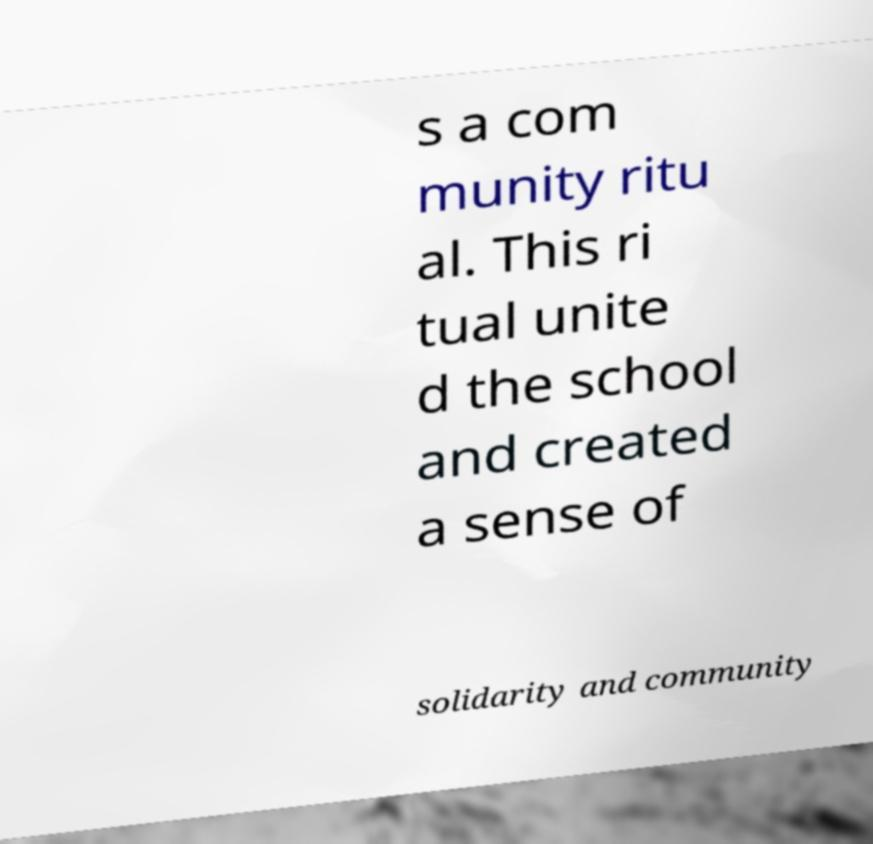Could you assist in decoding the text presented in this image and type it out clearly? s a com munity ritu al. This ri tual unite d the school and created a sense of solidarity and community 